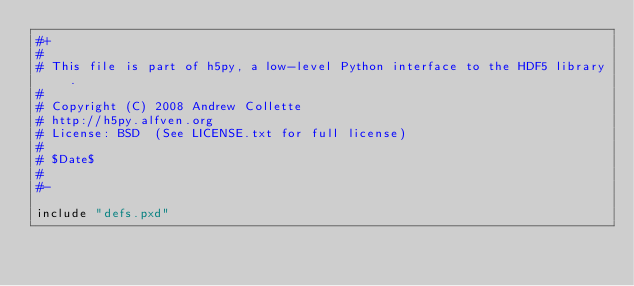<code> <loc_0><loc_0><loc_500><loc_500><_Cython_>#+
# 
# This file is part of h5py, a low-level Python interface to the HDF5 library.
# 
# Copyright (C) 2008 Andrew Collette
# http://h5py.alfven.org
# License: BSD  (See LICENSE.txt for full license)
# 
# $Date$
# 
#-

include "defs.pxd"

</code> 